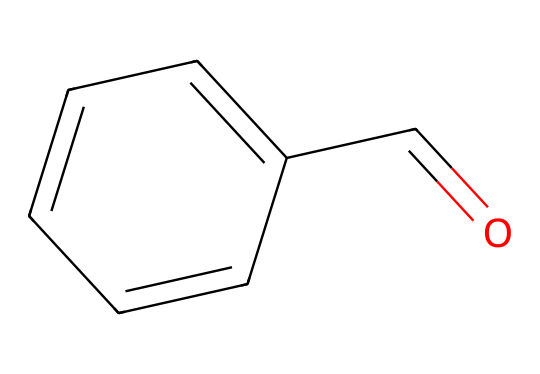what is the name of this chemical? The SMILES representation signifies the presence of a benzene ring and a formyl group, which corresponds to the structure of benzaldehyde.
Answer: benzaldehyde how many carbon atoms are in this structure? Analyzing the SMILES, there are six carbon atoms in the benzene ring and one carbon in the aldehyde group, totaling seven carbon atoms.
Answer: 7 how many bonds are present in the benzaldehyde molecule? From the visual structure, the benzaldehyde has 6 carbon-carbon bonds in the ring and one carbon-oxygen double bond and one carbon-hydrogen bond in the aldehyde functional group, totaling 8 bonds.
Answer: 8 what functional group is present in this chemical? The presence of the carbonyl (C=O) next to a benzene ring indicates the aldehyde functional group.
Answer: aldehyde what is the role of the aldehyde group in sealants? Aldehyde groups in sealants can contribute to cross-linking, which helps improve the strength and durability of the final product.
Answer: cross-linking how would the presence of benzaldehyde affect the properties of a sealant? Benzaldehyde can impart a pleasant aroma and may also enhance chemical resistance properties of the sealant due to its structure.
Answer: aroma and resistance how does the structure of benzaldehyde hint at its reactivity compared to other aldehydes? Benzaldehyde's aromatic ring stabilizes the molecule, but the carbonyl group is highly reactive, making it more suitable for reactions, especially in polymerization.
Answer: reactive due to carbonyl 